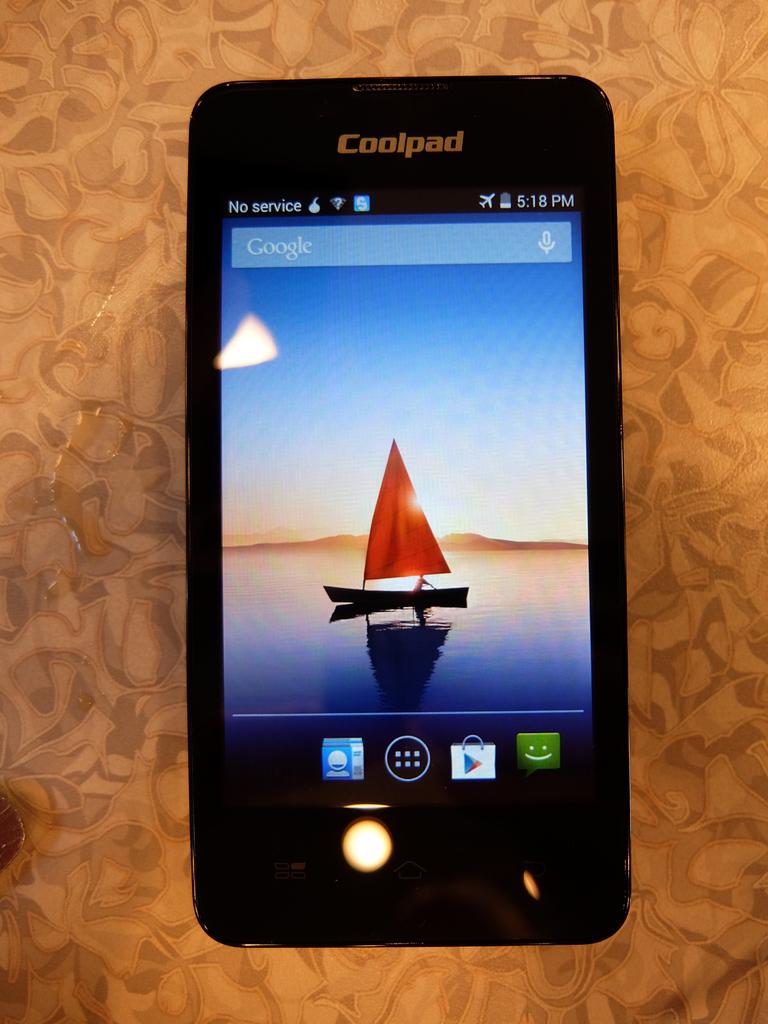What phone type is this?
Give a very brief answer. Coolpad. 